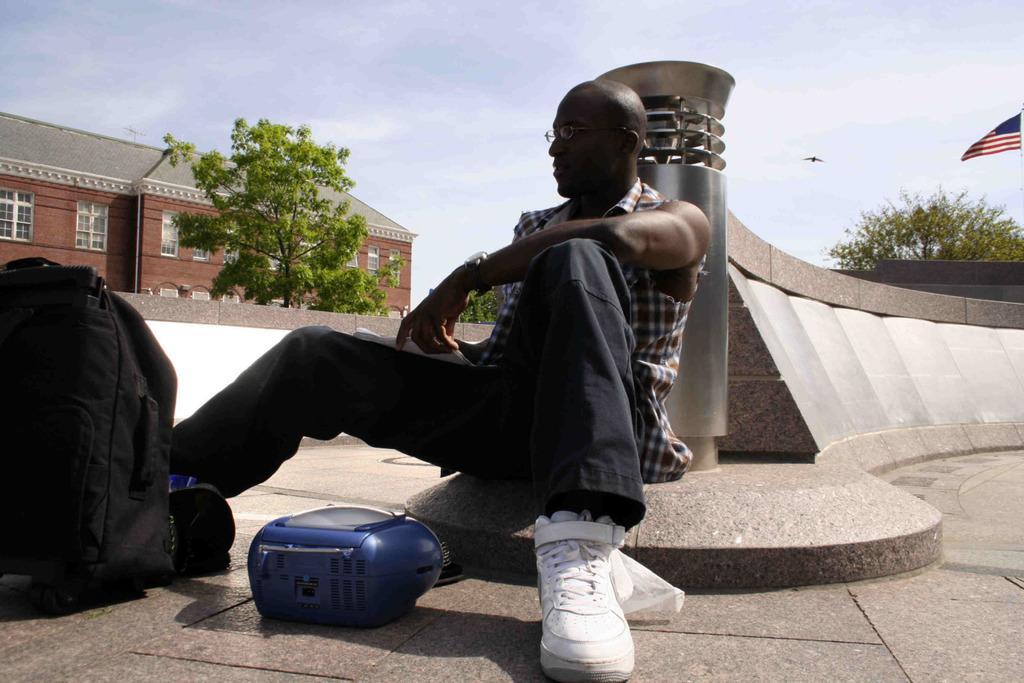Please provide a concise description of this image. This is the picture of a place where we have a person who is sitting on the floor and to the side there is a bag and behind there is a building, trees and a flag to the side. 